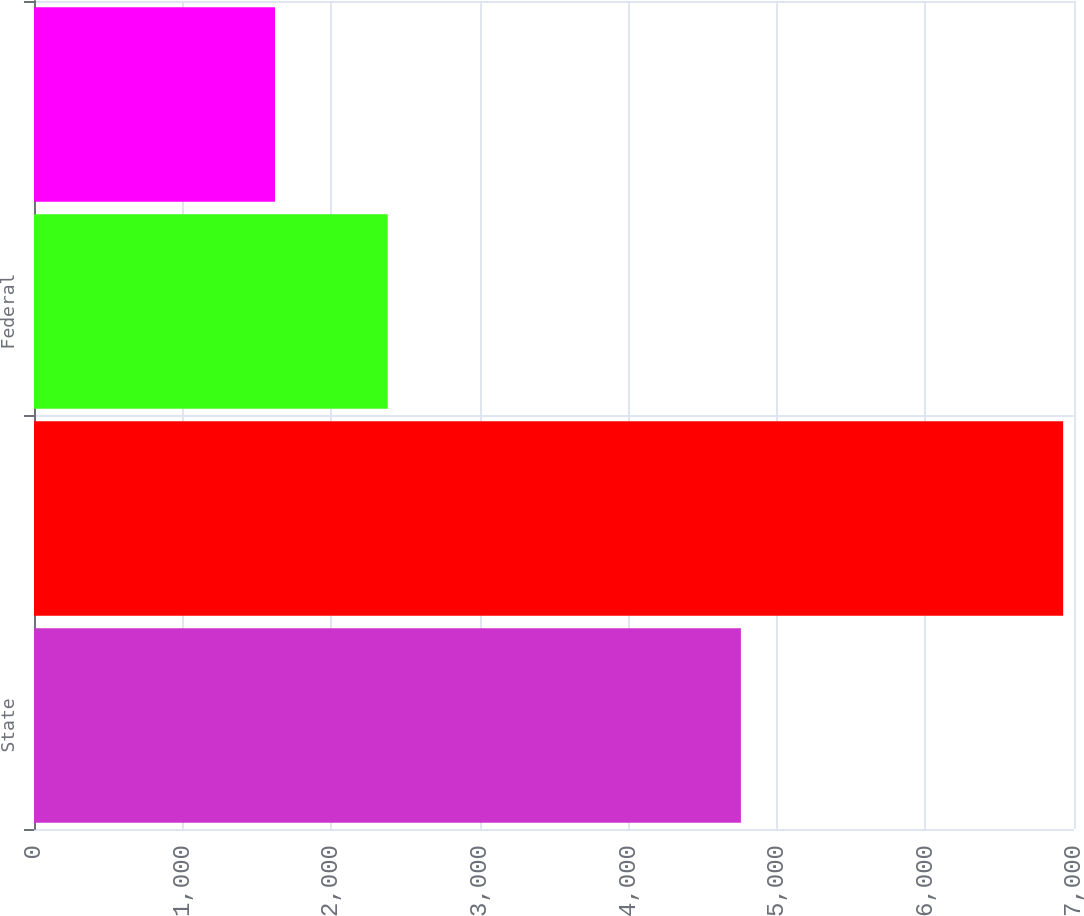Convert chart to OTSL. <chart><loc_0><loc_0><loc_500><loc_500><bar_chart><fcel>State<fcel>Foreign<fcel>Federal<fcel>Tax allocated to<nl><fcel>4758<fcel>6927<fcel>2381<fcel>1622<nl></chart> 